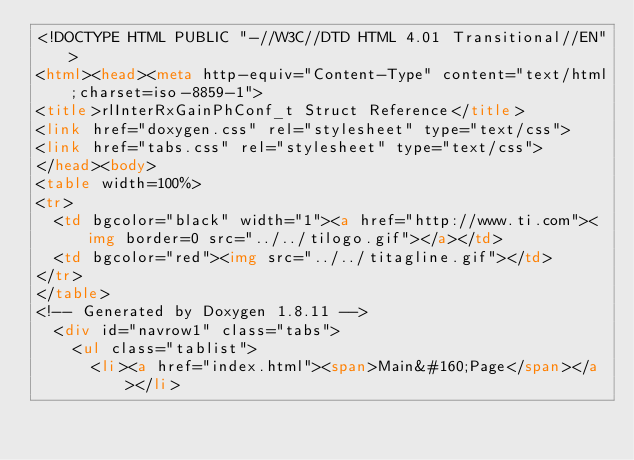Convert code to text. <code><loc_0><loc_0><loc_500><loc_500><_HTML_><!DOCTYPE HTML PUBLIC "-//W3C//DTD HTML 4.01 Transitional//EN">
<html><head><meta http-equiv="Content-Type" content="text/html;charset=iso-8859-1">
<title>rlInterRxGainPhConf_t Struct Reference</title>
<link href="doxygen.css" rel="stylesheet" type="text/css">
<link href="tabs.css" rel="stylesheet" type="text/css">
</head><body>
<table width=100%>
<tr>
  <td bgcolor="black" width="1"><a href="http://www.ti.com"><img border=0 src="../../tilogo.gif"></a></td>
  <td bgcolor="red"><img src="../../titagline.gif"></td>
</tr>
</table>
<!-- Generated by Doxygen 1.8.11 -->
  <div id="navrow1" class="tabs">
    <ul class="tablist">
      <li><a href="index.html"><span>Main&#160;Page</span></a></li></code> 